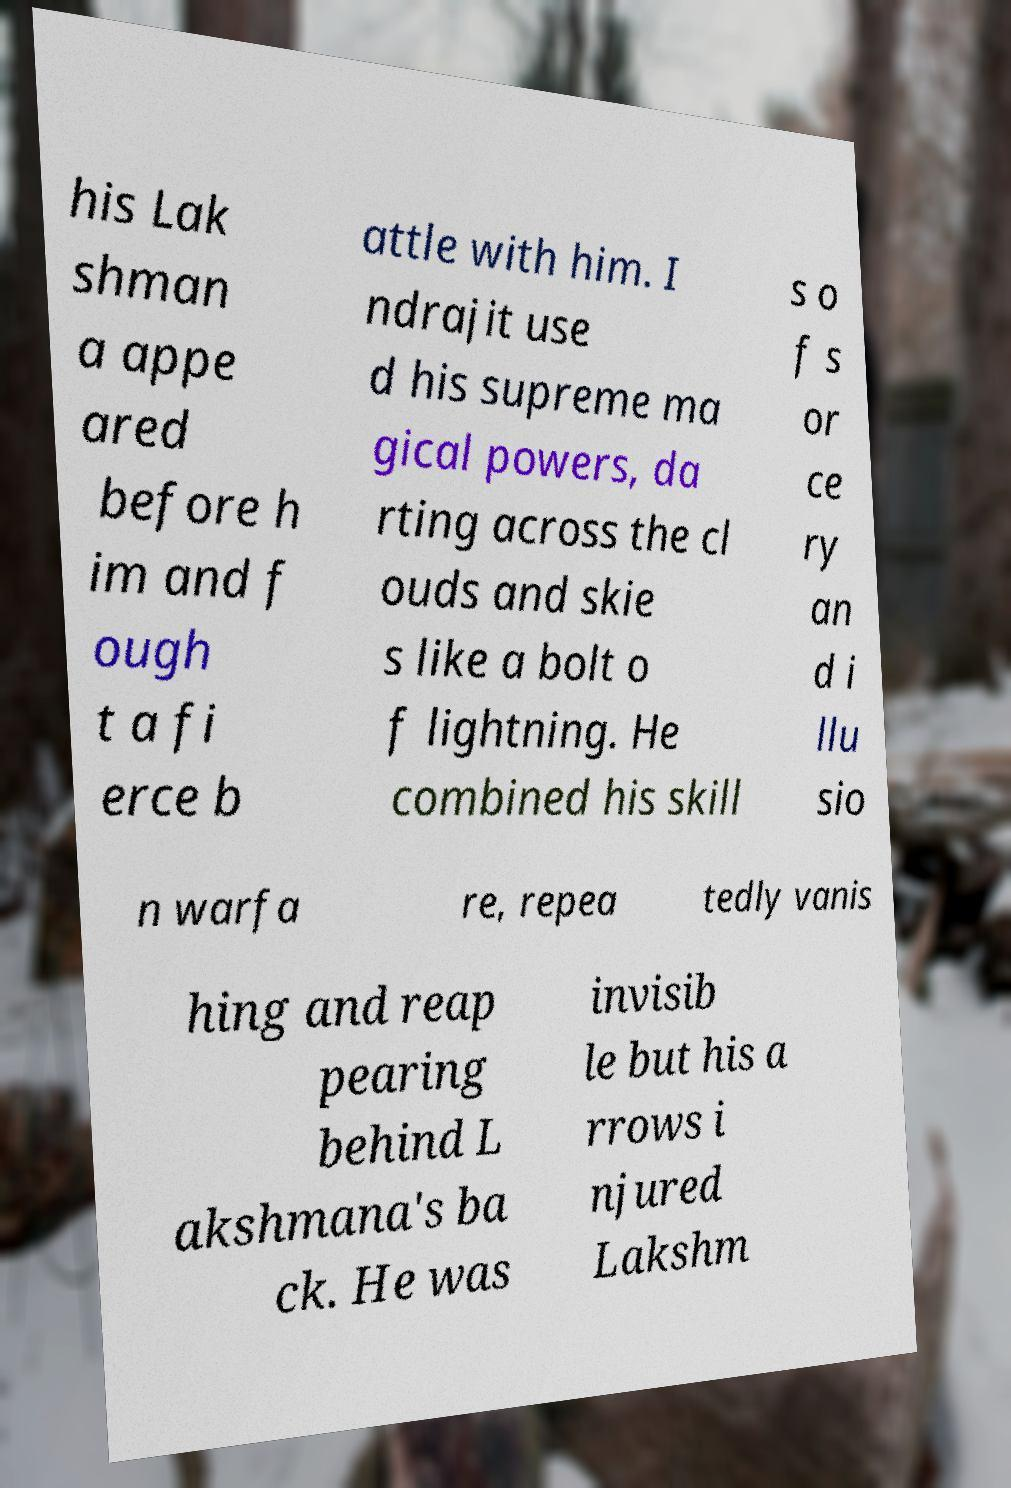Could you extract and type out the text from this image? his Lak shman a appe ared before h im and f ough t a fi erce b attle with him. I ndrajit use d his supreme ma gical powers, da rting across the cl ouds and skie s like a bolt o f lightning. He combined his skill s o f s or ce ry an d i llu sio n warfa re, repea tedly vanis hing and reap pearing behind L akshmana's ba ck. He was invisib le but his a rrows i njured Lakshm 